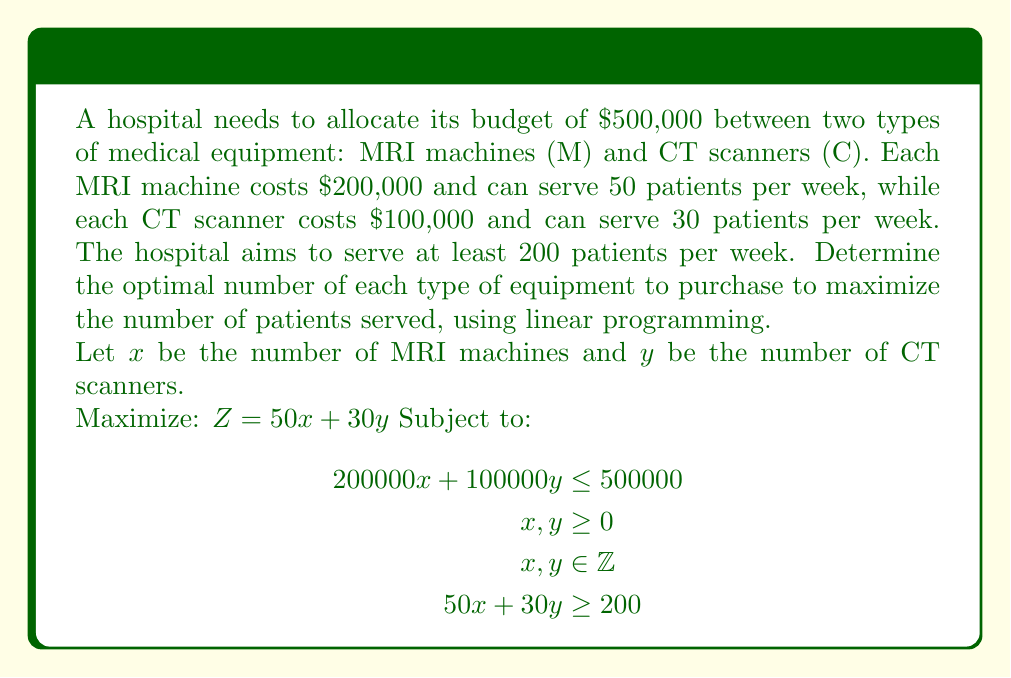Can you solve this math problem? To solve this linear programming problem, we'll follow these steps:

1) First, simplify the budget constraint:
   $200000x + 100000y \leq 500000$ becomes $2x + y \leq 5$

2) The constraints are now:
   $$\begin{align}
   2x + y &\leq 5 \\
   50x + 30y &\geq 200 \\
   x, y &\geq 0 \\
   x, y &\in \mathbb{Z}
   \end{align}$$

3) Plot these constraints:
   [asy]
   import graph;
   size(200);
   xaxis("x", 0, 5, Arrow);
   yaxis("y", 0, 5, Arrow);
   draw((0,5)--(2.5,0), blue);
   draw((4,0)--(0,20/3), red);
   label("2x + y = 5", (1,3), W, blue);
   label("50x + 30y = 200", (2,2), SE, red);
   dot((2,1)); dot((1,3)); dot((0,4));
   label("(2,1)", (2,1), SE);
   label("(1,3)", (1,3), NW);
   label("(0,4)", (0,4), E);
   [/asy]

4) The feasible integer points are (0,4), (1,3), and (2,1).

5) Evaluate the objective function $Z = 50x + 30y$ at each point:
   - At (0,4): $Z = 50(0) + 30(4) = 120$
   - At (1,3): $Z = 50(1) + 30(3) = 140$
   - At (2,1): $Z = 50(2) + 30(1) = 130$

6) The maximum value of $Z$ occurs at (1,3), which corresponds to 1 MRI machine and 3 CT scanners.
Answer: 1 MRI machine, 3 CT scanners 